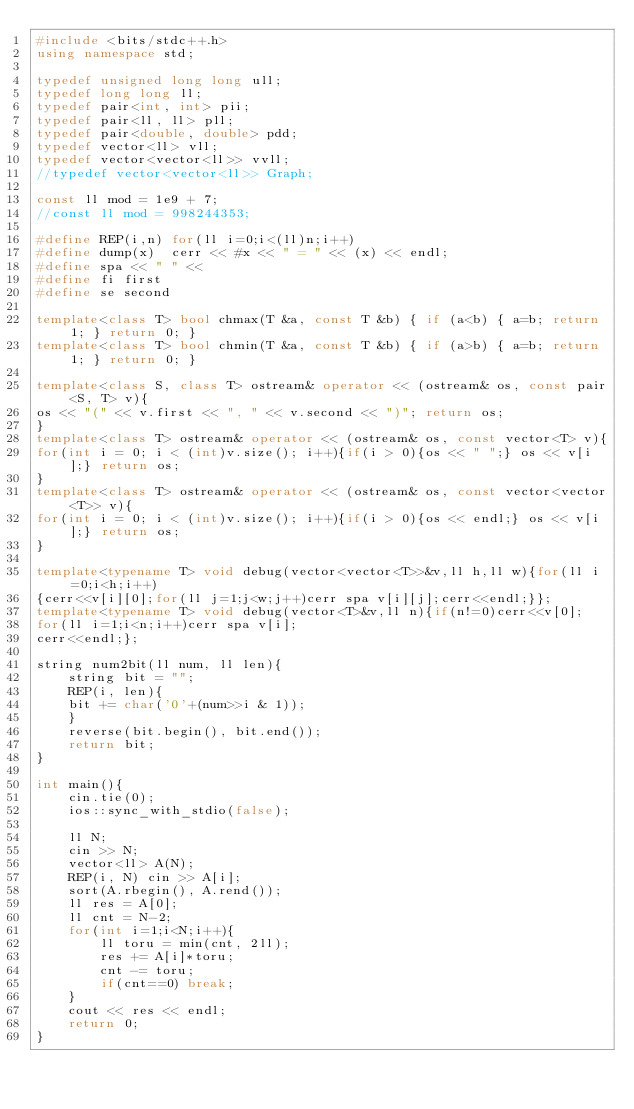<code> <loc_0><loc_0><loc_500><loc_500><_C++_>#include <bits/stdc++.h>
using namespace std;

typedef unsigned long long ull;
typedef long long ll;
typedef pair<int, int> pii;
typedef pair<ll, ll> pll;
typedef pair<double, double> pdd;
typedef vector<ll> vll;
typedef vector<vector<ll>> vvll;
//typedef vector<vector<ll>> Graph;

const ll mod = 1e9 + 7;
//const ll mod = 998244353;

#define REP(i,n) for(ll i=0;i<(ll)n;i++)
#define dump(x)  cerr << #x << " = " << (x) << endl;
#define spa << " " <<
#define fi first
#define se second

template<class T> bool chmax(T &a, const T &b) { if (a<b) { a=b; return 1; } return 0; }
template<class T> bool chmin(T &a, const T &b) { if (a>b) { a=b; return 1; } return 0; }

template<class S, class T> ostream& operator << (ostream& os, const pair<S, T> v){
os << "(" << v.first << ", " << v.second << ")"; return os;
}
template<class T> ostream& operator << (ostream& os, const vector<T> v){
for(int i = 0; i < (int)v.size(); i++){if(i > 0){os << " ";} os << v[i];} return os;
}
template<class T> ostream& operator << (ostream& os, const vector<vector<T>> v){
for(int i = 0; i < (int)v.size(); i++){if(i > 0){os << endl;} os << v[i];} return os;
}

template<typename T> void debug(vector<vector<T>>&v,ll h,ll w){for(ll i=0;i<h;i++)
{cerr<<v[i][0];for(ll j=1;j<w;j++)cerr spa v[i][j];cerr<<endl;}};
template<typename T> void debug(vector<T>&v,ll n){if(n!=0)cerr<<v[0];
for(ll i=1;i<n;i++)cerr spa v[i];
cerr<<endl;};

string num2bit(ll num, ll len){
    string bit = "";
    REP(i, len){
    bit += char('0'+(num>>i & 1));
    }
    reverse(bit.begin(), bit.end());
    return bit;
}

int main(){
    cin.tie(0);
    ios::sync_with_stdio(false);

    ll N;
    cin >> N;
    vector<ll> A(N);
    REP(i, N) cin >> A[i];
    sort(A.rbegin(), A.rend());
    ll res = A[0];
    ll cnt = N-2;
    for(int i=1;i<N;i++){
        ll toru = min(cnt, 2ll);
        res += A[i]*toru;
        cnt -= toru;
        if(cnt==0) break;
    }
    cout << res << endl;
    return 0;
}</code> 